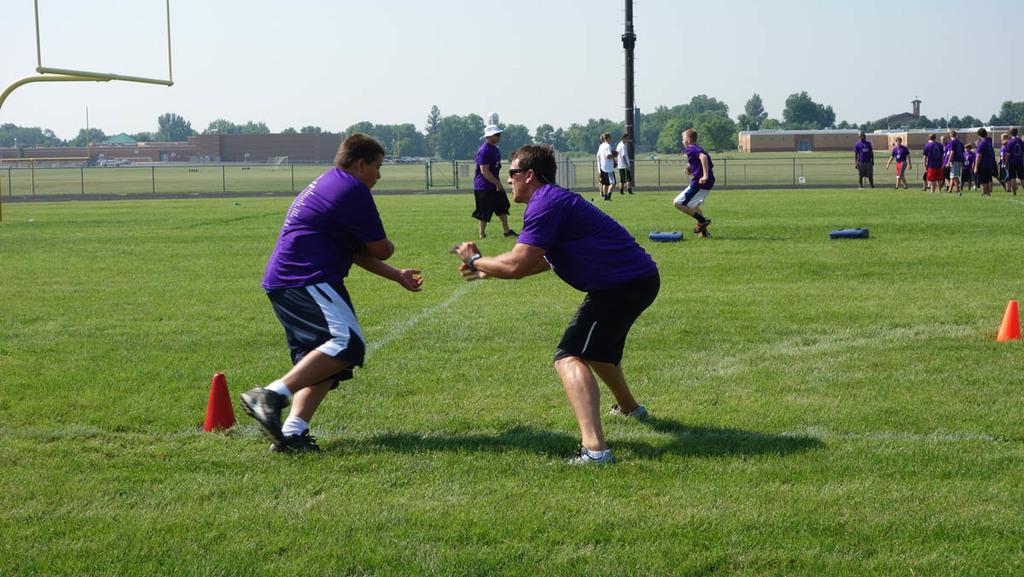Could you give a brief overview of what you see in this image? In this picture there are two people standing and in the foreground and they might be playing. At the back there are group of people and there are buildings and trees and there are poles. At the top left there is an object. At the top there is sky. At the bottom there is grass and there are objects on the grass. 